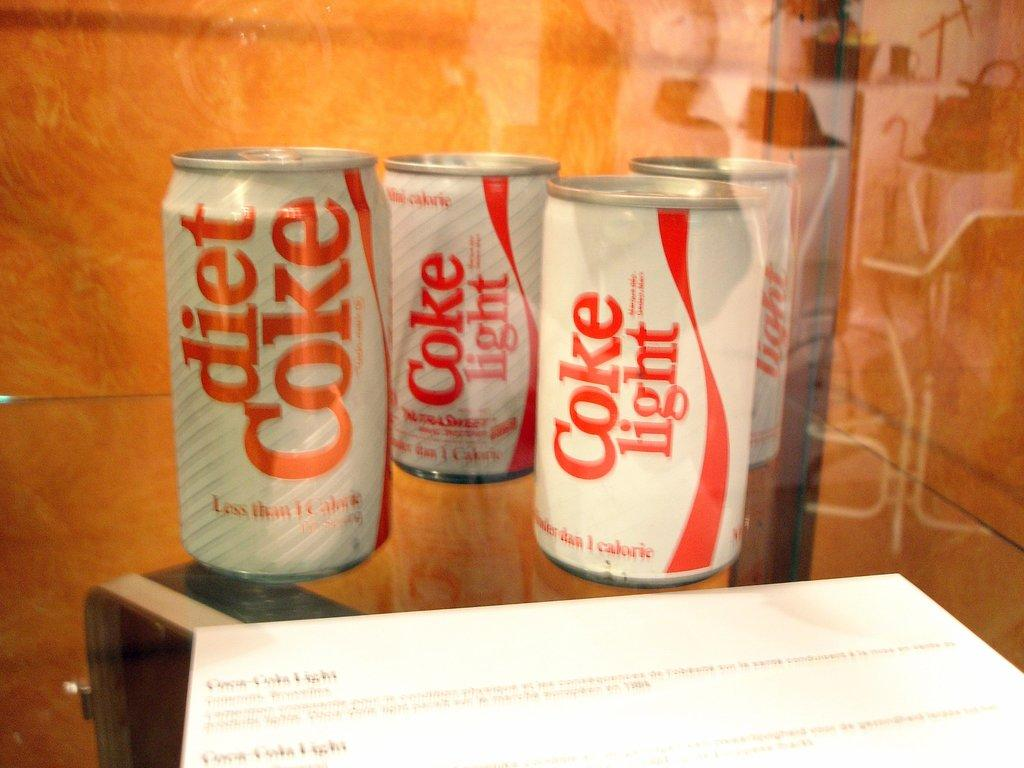Provide a one-sentence caption for the provided image. Several cans of Coke Light are standing near each other in front of a white paper. 